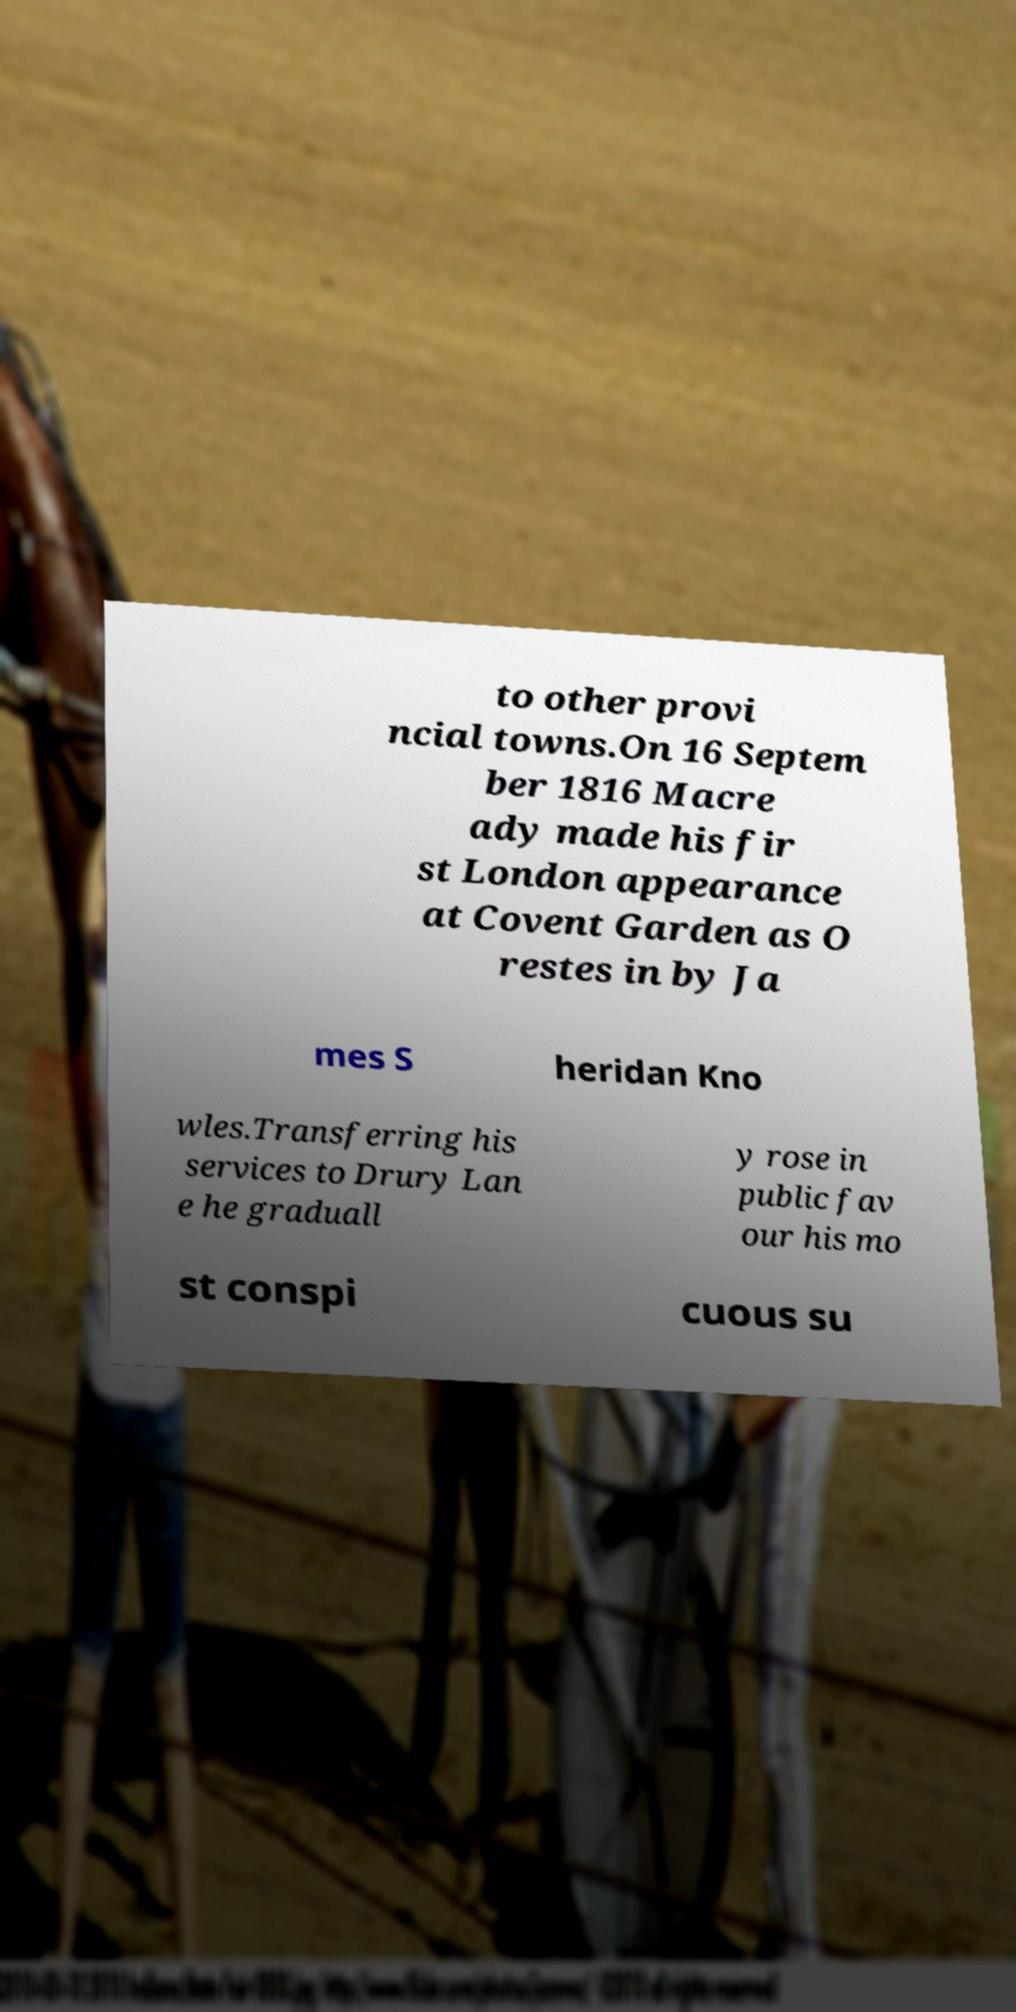Could you extract and type out the text from this image? to other provi ncial towns.On 16 Septem ber 1816 Macre ady made his fir st London appearance at Covent Garden as O restes in by Ja mes S heridan Kno wles.Transferring his services to Drury Lan e he graduall y rose in public fav our his mo st conspi cuous su 